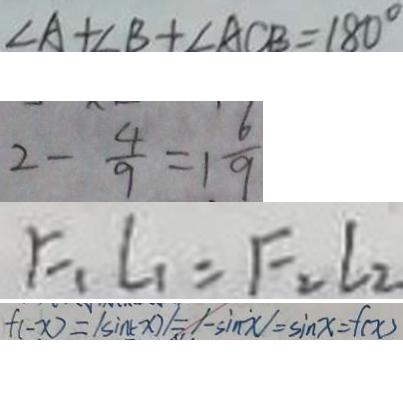<formula> <loc_0><loc_0><loc_500><loc_500>\angle A + B + \angle A C B = 1 8 0 ^ { \circ } 
 2 - \frac { 4 } { 9 } = 1 \frac { 6 } { 9 } 
 F _ { 1 } L _ { 1 } = F _ { 2 } L _ { 2 } 
 f ( - x ) = \vert - \sin ( - x ) \vert = \vert - \sin x \vert = \sin x = f ( x )</formula> 